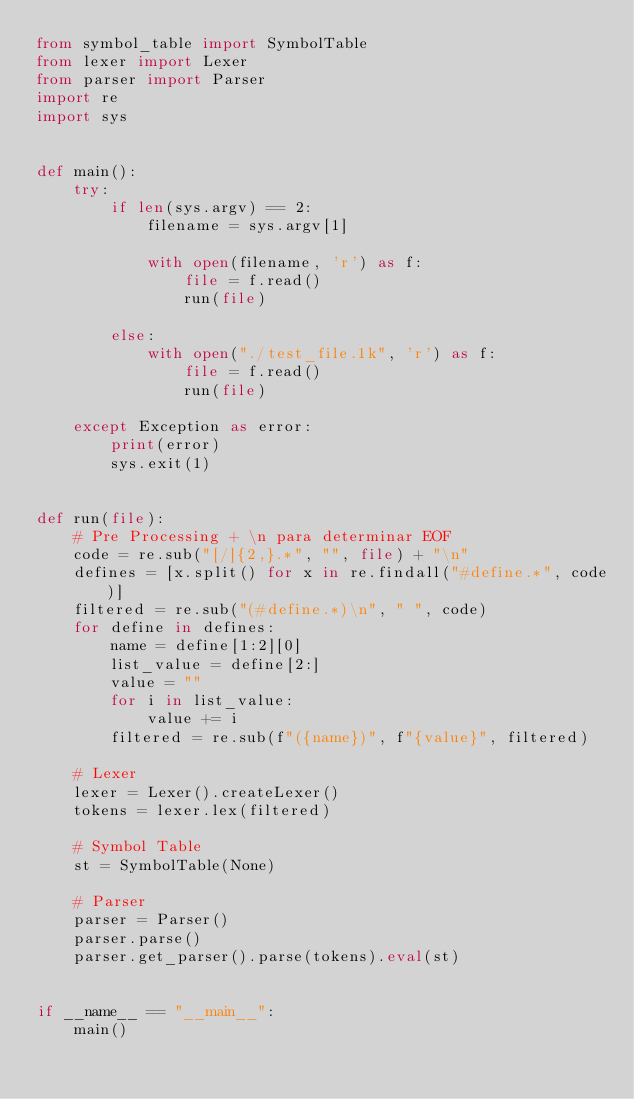Convert code to text. <code><loc_0><loc_0><loc_500><loc_500><_Python_>from symbol_table import SymbolTable
from lexer import Lexer
from parser import Parser
import re
import sys


def main():
    try:
        if len(sys.argv) == 2:
            filename = sys.argv[1]

            with open(filename, 'r') as f:
                file = f.read()
                run(file)

        else:
            with open("./test_file.1k", 'r') as f:
                file = f.read()
                run(file)

    except Exception as error:
        print(error)
        sys.exit(1)


def run(file):
    # Pre Processing + \n para determinar EOF
    code = re.sub("[/]{2,}.*", "", file) + "\n"
    defines = [x.split() for x in re.findall("#define.*", code)]
    filtered = re.sub("(#define.*)\n", " ", code)
    for define in defines:
        name = define[1:2][0]
        list_value = define[2:]
        value = ""
        for i in list_value:
            value += i
        filtered = re.sub(f"({name})", f"{value}", filtered)

    # Lexer
    lexer = Lexer().createLexer()
    tokens = lexer.lex(filtered)

    # Symbol Table
    st = SymbolTable(None)

    # Parser
    parser = Parser()
    parser.parse()
    parser.get_parser().parse(tokens).eval(st)


if __name__ == "__main__":
    main()
</code> 